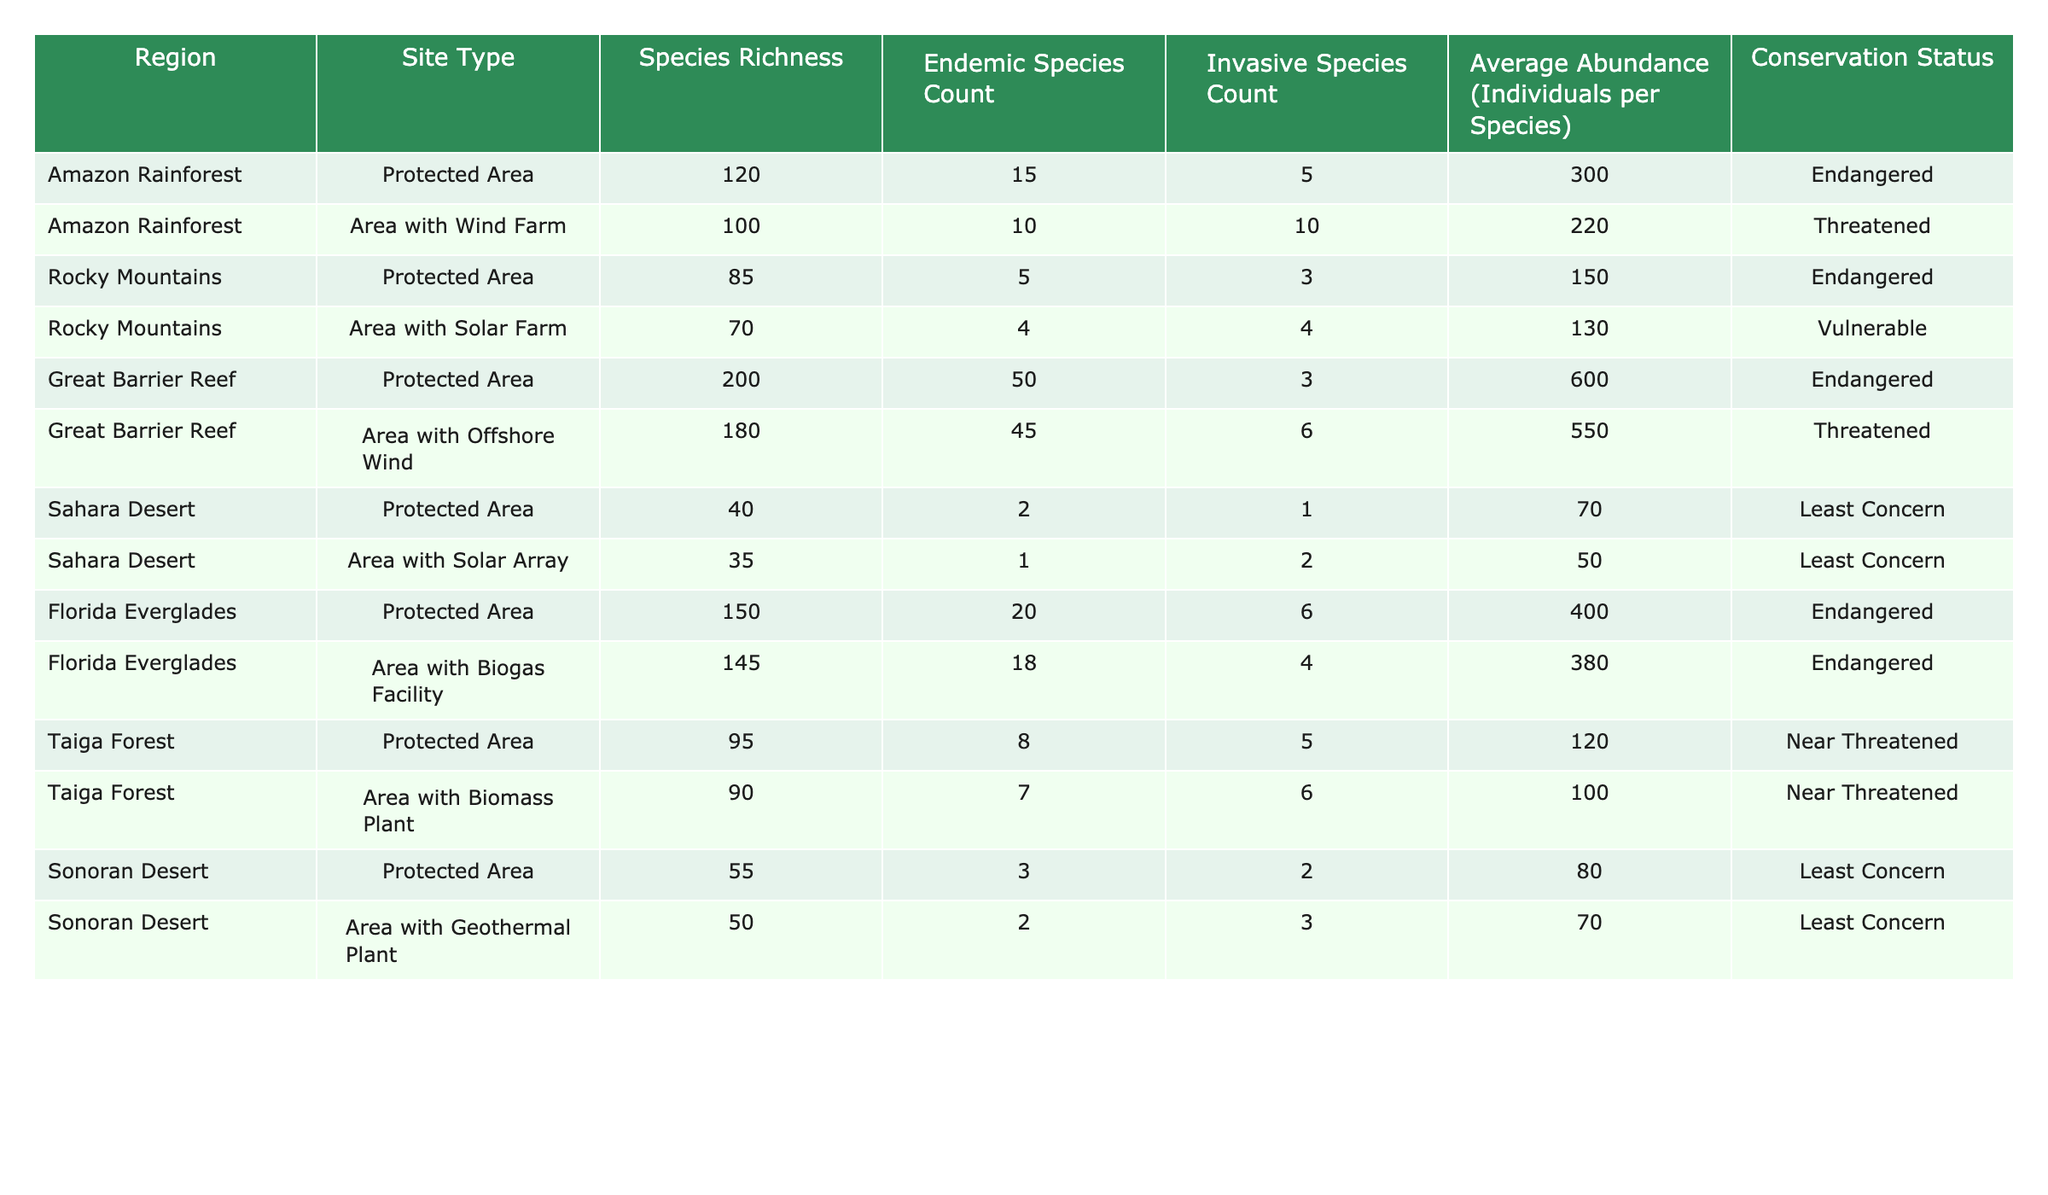What's the species richness in the Great Barrier Reef protected area? The table shows that the species richness in the Great Barrier Reef protected area is listed as 200.
Answer: 200 How many invasive species are found in the Rocky Mountains area with solar farm? According to the table, the Rocky Mountains area with a solar farm has 4 invasive species.
Answer: 4 What is the conservation status of the Sahara Desert protected area? The table indicates that the conservation status of the Sahara Desert protected area is "Least Concern."
Answer: Least Concern What is the average abundance of species in the area with a wind farm compared to the protected area in the Amazon Rainforest? In the Amazon Rainforest, the protected area has an average abundance of 300 individuals per species, while the area with a wind farm has an average abundance of 220. The difference shows that the protected area has a higher average abundance.
Answer: 300 vs 220 How many total endemic species are there between the two areas with renewable energy systems in the Amazon Rainforest and Great Barrier Reef? The Amazon Rainforest area with a wind farm has 10 endemic species, and the Great Barrier Reef area with offshore wind has 45. Adding these gives 10 + 45 = 55 endemic species in total.
Answer: 55 Is the average abundance in the Florida Everglades area with a biogas facility higher than in the Sahara Desert area with a solar array? The average abundance in the Florida Everglades area with a biogas facility is 380, while the Sahara Desert area with a solar array has 50. Since 380 > 50, the statement is true.
Answer: Yes Which protected area has the highest count of endemic species? The table lists the Great Barrier Reef protected area with 50 endemic species as having the highest count compared to others.
Answer: Great Barrier Reef How does the species richness in the Sonoran Desert compare between the protected area and the area with the geothermal plant? The protected area in the Sonoran Desert has a species richness of 55, while the area with the geothermal plant has 50. The protected area exhibits higher species richness by 5 species.
Answer: 5 more in the protected area What is the total number of invasive species across all areas with renewable energy systems? Summing the invasive species count from all renewable energy system areas: 10 (Amazon) + 4 (Rocky Mountains) + 6 (Great Barrier Reef) + 2 (Sahara Desert) + 4 (Florida Everglades) + 3 (Taiga Forest) + 3 (Sonoran Desert) gives a total of 32 invasive species.
Answer: 32 Is the conservation status of the protected areas generally more favorable than that of the areas with renewable energy systems? By comparing the conservation status of all protected areas and energy areas, protected areas include "Endangered," "Near Threatened," and "Least Concern." Energy areas show "Threatened," "Vulnerable," and "Least Concern." Most protected areas have a lower status than the energy areas, indicating a less favorable status.
Answer: No 